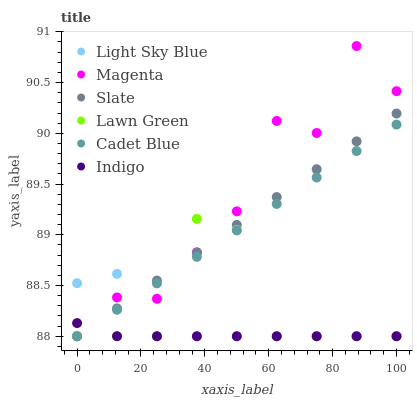Does Indigo have the minimum area under the curve?
Answer yes or no. Yes. Does Magenta have the maximum area under the curve?
Answer yes or no. Yes. Does Cadet Blue have the minimum area under the curve?
Answer yes or no. No. Does Cadet Blue have the maximum area under the curve?
Answer yes or no. No. Is Cadet Blue the smoothest?
Answer yes or no. Yes. Is Magenta the roughest?
Answer yes or no. Yes. Is Indigo the smoothest?
Answer yes or no. No. Is Indigo the roughest?
Answer yes or no. No. Does Lawn Green have the lowest value?
Answer yes or no. Yes. Does Magenta have the highest value?
Answer yes or no. Yes. Does Cadet Blue have the highest value?
Answer yes or no. No. Does Magenta intersect Light Sky Blue?
Answer yes or no. Yes. Is Magenta less than Light Sky Blue?
Answer yes or no. No. Is Magenta greater than Light Sky Blue?
Answer yes or no. No. 